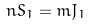<formula> <loc_0><loc_0><loc_500><loc_500>n S _ { 1 } = m J _ { 1 }</formula> 